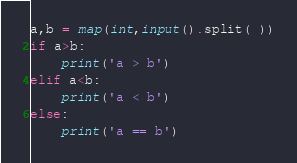<code> <loc_0><loc_0><loc_500><loc_500><_Python_>a,b = map(int,input().split( ))
if a>b:
    print('a > b')
elif a<b:
    print('a < b')
else: 
    print('a == b')


</code> 